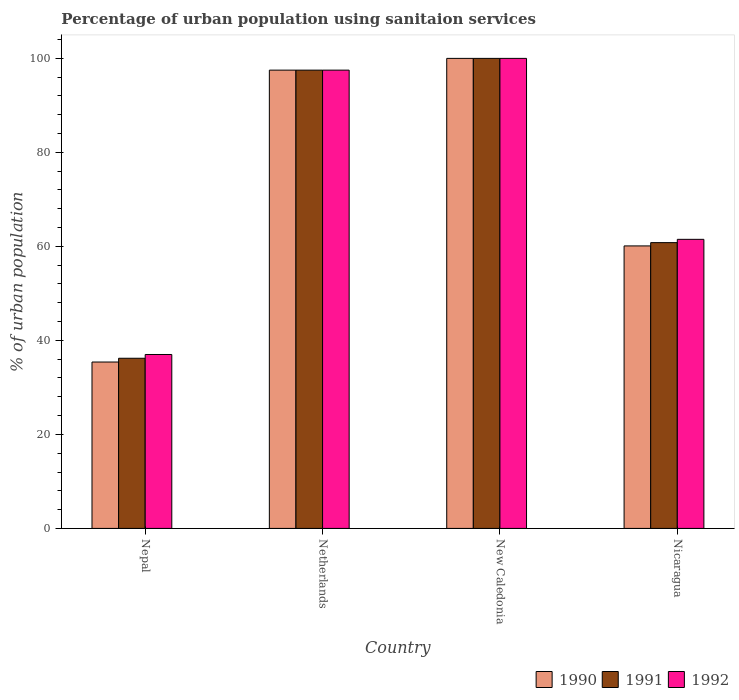Are the number of bars per tick equal to the number of legend labels?
Your answer should be very brief. Yes. How many bars are there on the 1st tick from the right?
Offer a very short reply. 3. What is the label of the 4th group of bars from the left?
Make the answer very short. Nicaragua. In how many cases, is the number of bars for a given country not equal to the number of legend labels?
Offer a terse response. 0. What is the percentage of urban population using sanitaion services in 1992 in Netherlands?
Offer a very short reply. 97.5. Across all countries, what is the maximum percentage of urban population using sanitaion services in 1990?
Your answer should be very brief. 100. Across all countries, what is the minimum percentage of urban population using sanitaion services in 1992?
Keep it short and to the point. 37. In which country was the percentage of urban population using sanitaion services in 1990 maximum?
Keep it short and to the point. New Caledonia. In which country was the percentage of urban population using sanitaion services in 1992 minimum?
Provide a short and direct response. Nepal. What is the total percentage of urban population using sanitaion services in 1990 in the graph?
Your answer should be very brief. 293. What is the difference between the percentage of urban population using sanitaion services in 1991 in Nepal and that in Nicaragua?
Make the answer very short. -24.6. What is the difference between the percentage of urban population using sanitaion services in 1992 in Nepal and the percentage of urban population using sanitaion services in 1990 in Netherlands?
Provide a short and direct response. -60.5. What is the average percentage of urban population using sanitaion services in 1992 per country?
Keep it short and to the point. 74. What is the difference between the percentage of urban population using sanitaion services of/in 1990 and percentage of urban population using sanitaion services of/in 1991 in Netherlands?
Your answer should be very brief. 0. What is the ratio of the percentage of urban population using sanitaion services in 1990 in Netherlands to that in New Caledonia?
Keep it short and to the point. 0.97. Is the percentage of urban population using sanitaion services in 1992 in Netherlands less than that in New Caledonia?
Keep it short and to the point. Yes. Is the difference between the percentage of urban population using sanitaion services in 1990 in Nepal and Nicaragua greater than the difference between the percentage of urban population using sanitaion services in 1991 in Nepal and Nicaragua?
Your response must be concise. No. What is the difference between the highest and the second highest percentage of urban population using sanitaion services in 1990?
Your response must be concise. -2.5. What is the difference between the highest and the lowest percentage of urban population using sanitaion services in 1991?
Keep it short and to the point. 63.8. Is the sum of the percentage of urban population using sanitaion services in 1992 in Netherlands and Nicaragua greater than the maximum percentage of urban population using sanitaion services in 1991 across all countries?
Offer a very short reply. Yes. How many bars are there?
Give a very brief answer. 12. What is the difference between two consecutive major ticks on the Y-axis?
Offer a terse response. 20. Are the values on the major ticks of Y-axis written in scientific E-notation?
Give a very brief answer. No. Does the graph contain any zero values?
Offer a very short reply. No. What is the title of the graph?
Offer a terse response. Percentage of urban population using sanitaion services. Does "1964" appear as one of the legend labels in the graph?
Provide a short and direct response. No. What is the label or title of the X-axis?
Your answer should be very brief. Country. What is the label or title of the Y-axis?
Your response must be concise. % of urban population. What is the % of urban population of 1990 in Nepal?
Keep it short and to the point. 35.4. What is the % of urban population in 1991 in Nepal?
Your answer should be very brief. 36.2. What is the % of urban population of 1990 in Netherlands?
Provide a succinct answer. 97.5. What is the % of urban population in 1991 in Netherlands?
Provide a short and direct response. 97.5. What is the % of urban population of 1992 in Netherlands?
Your answer should be compact. 97.5. What is the % of urban population of 1991 in New Caledonia?
Make the answer very short. 100. What is the % of urban population in 1990 in Nicaragua?
Offer a terse response. 60.1. What is the % of urban population of 1991 in Nicaragua?
Provide a succinct answer. 60.8. What is the % of urban population of 1992 in Nicaragua?
Your answer should be compact. 61.5. Across all countries, what is the maximum % of urban population in 1990?
Make the answer very short. 100. Across all countries, what is the minimum % of urban population in 1990?
Offer a very short reply. 35.4. Across all countries, what is the minimum % of urban population of 1991?
Make the answer very short. 36.2. What is the total % of urban population of 1990 in the graph?
Offer a very short reply. 293. What is the total % of urban population of 1991 in the graph?
Your answer should be very brief. 294.5. What is the total % of urban population of 1992 in the graph?
Your answer should be compact. 296. What is the difference between the % of urban population in 1990 in Nepal and that in Netherlands?
Provide a short and direct response. -62.1. What is the difference between the % of urban population of 1991 in Nepal and that in Netherlands?
Provide a short and direct response. -61.3. What is the difference between the % of urban population of 1992 in Nepal and that in Netherlands?
Provide a short and direct response. -60.5. What is the difference between the % of urban population of 1990 in Nepal and that in New Caledonia?
Ensure brevity in your answer.  -64.6. What is the difference between the % of urban population in 1991 in Nepal and that in New Caledonia?
Your answer should be very brief. -63.8. What is the difference between the % of urban population in 1992 in Nepal and that in New Caledonia?
Provide a succinct answer. -63. What is the difference between the % of urban population of 1990 in Nepal and that in Nicaragua?
Ensure brevity in your answer.  -24.7. What is the difference between the % of urban population of 1991 in Nepal and that in Nicaragua?
Your answer should be compact. -24.6. What is the difference between the % of urban population in 1992 in Nepal and that in Nicaragua?
Give a very brief answer. -24.5. What is the difference between the % of urban population of 1990 in Netherlands and that in New Caledonia?
Your answer should be very brief. -2.5. What is the difference between the % of urban population of 1991 in Netherlands and that in New Caledonia?
Your response must be concise. -2.5. What is the difference between the % of urban population of 1990 in Netherlands and that in Nicaragua?
Ensure brevity in your answer.  37.4. What is the difference between the % of urban population in 1991 in Netherlands and that in Nicaragua?
Keep it short and to the point. 36.7. What is the difference between the % of urban population of 1990 in New Caledonia and that in Nicaragua?
Keep it short and to the point. 39.9. What is the difference between the % of urban population of 1991 in New Caledonia and that in Nicaragua?
Give a very brief answer. 39.2. What is the difference between the % of urban population of 1992 in New Caledonia and that in Nicaragua?
Offer a terse response. 38.5. What is the difference between the % of urban population in 1990 in Nepal and the % of urban population in 1991 in Netherlands?
Give a very brief answer. -62.1. What is the difference between the % of urban population in 1990 in Nepal and the % of urban population in 1992 in Netherlands?
Ensure brevity in your answer.  -62.1. What is the difference between the % of urban population in 1991 in Nepal and the % of urban population in 1992 in Netherlands?
Your answer should be compact. -61.3. What is the difference between the % of urban population in 1990 in Nepal and the % of urban population in 1991 in New Caledonia?
Provide a succinct answer. -64.6. What is the difference between the % of urban population in 1990 in Nepal and the % of urban population in 1992 in New Caledonia?
Offer a very short reply. -64.6. What is the difference between the % of urban population in 1991 in Nepal and the % of urban population in 1992 in New Caledonia?
Keep it short and to the point. -63.8. What is the difference between the % of urban population of 1990 in Nepal and the % of urban population of 1991 in Nicaragua?
Offer a terse response. -25.4. What is the difference between the % of urban population in 1990 in Nepal and the % of urban population in 1992 in Nicaragua?
Keep it short and to the point. -26.1. What is the difference between the % of urban population of 1991 in Nepal and the % of urban population of 1992 in Nicaragua?
Offer a very short reply. -25.3. What is the difference between the % of urban population in 1990 in Netherlands and the % of urban population in 1991 in New Caledonia?
Ensure brevity in your answer.  -2.5. What is the difference between the % of urban population in 1991 in Netherlands and the % of urban population in 1992 in New Caledonia?
Make the answer very short. -2.5. What is the difference between the % of urban population of 1990 in Netherlands and the % of urban population of 1991 in Nicaragua?
Offer a very short reply. 36.7. What is the difference between the % of urban population of 1990 in Netherlands and the % of urban population of 1992 in Nicaragua?
Keep it short and to the point. 36. What is the difference between the % of urban population in 1991 in Netherlands and the % of urban population in 1992 in Nicaragua?
Offer a very short reply. 36. What is the difference between the % of urban population in 1990 in New Caledonia and the % of urban population in 1991 in Nicaragua?
Your response must be concise. 39.2. What is the difference between the % of urban population of 1990 in New Caledonia and the % of urban population of 1992 in Nicaragua?
Your answer should be compact. 38.5. What is the difference between the % of urban population of 1991 in New Caledonia and the % of urban population of 1992 in Nicaragua?
Offer a terse response. 38.5. What is the average % of urban population in 1990 per country?
Your response must be concise. 73.25. What is the average % of urban population in 1991 per country?
Make the answer very short. 73.62. What is the difference between the % of urban population in 1990 and % of urban population in 1992 in Nepal?
Provide a short and direct response. -1.6. What is the difference between the % of urban population in 1991 and % of urban population in 1992 in Netherlands?
Keep it short and to the point. 0. What is the difference between the % of urban population in 1991 and % of urban population in 1992 in New Caledonia?
Keep it short and to the point. 0. What is the difference between the % of urban population in 1990 and % of urban population in 1991 in Nicaragua?
Make the answer very short. -0.7. What is the ratio of the % of urban population of 1990 in Nepal to that in Netherlands?
Make the answer very short. 0.36. What is the ratio of the % of urban population of 1991 in Nepal to that in Netherlands?
Keep it short and to the point. 0.37. What is the ratio of the % of urban population of 1992 in Nepal to that in Netherlands?
Provide a succinct answer. 0.38. What is the ratio of the % of urban population of 1990 in Nepal to that in New Caledonia?
Offer a very short reply. 0.35. What is the ratio of the % of urban population of 1991 in Nepal to that in New Caledonia?
Offer a very short reply. 0.36. What is the ratio of the % of urban population of 1992 in Nepal to that in New Caledonia?
Your answer should be very brief. 0.37. What is the ratio of the % of urban population of 1990 in Nepal to that in Nicaragua?
Give a very brief answer. 0.59. What is the ratio of the % of urban population in 1991 in Nepal to that in Nicaragua?
Your response must be concise. 0.6. What is the ratio of the % of urban population of 1992 in Nepal to that in Nicaragua?
Provide a short and direct response. 0.6. What is the ratio of the % of urban population of 1991 in Netherlands to that in New Caledonia?
Provide a short and direct response. 0.97. What is the ratio of the % of urban population in 1990 in Netherlands to that in Nicaragua?
Offer a very short reply. 1.62. What is the ratio of the % of urban population of 1991 in Netherlands to that in Nicaragua?
Your answer should be very brief. 1.6. What is the ratio of the % of urban population in 1992 in Netherlands to that in Nicaragua?
Ensure brevity in your answer.  1.59. What is the ratio of the % of urban population of 1990 in New Caledonia to that in Nicaragua?
Give a very brief answer. 1.66. What is the ratio of the % of urban population of 1991 in New Caledonia to that in Nicaragua?
Provide a succinct answer. 1.64. What is the ratio of the % of urban population of 1992 in New Caledonia to that in Nicaragua?
Provide a short and direct response. 1.63. What is the difference between the highest and the second highest % of urban population of 1990?
Your response must be concise. 2.5. What is the difference between the highest and the second highest % of urban population of 1991?
Provide a succinct answer. 2.5. What is the difference between the highest and the second highest % of urban population in 1992?
Your response must be concise. 2.5. What is the difference between the highest and the lowest % of urban population of 1990?
Provide a succinct answer. 64.6. What is the difference between the highest and the lowest % of urban population in 1991?
Give a very brief answer. 63.8. 